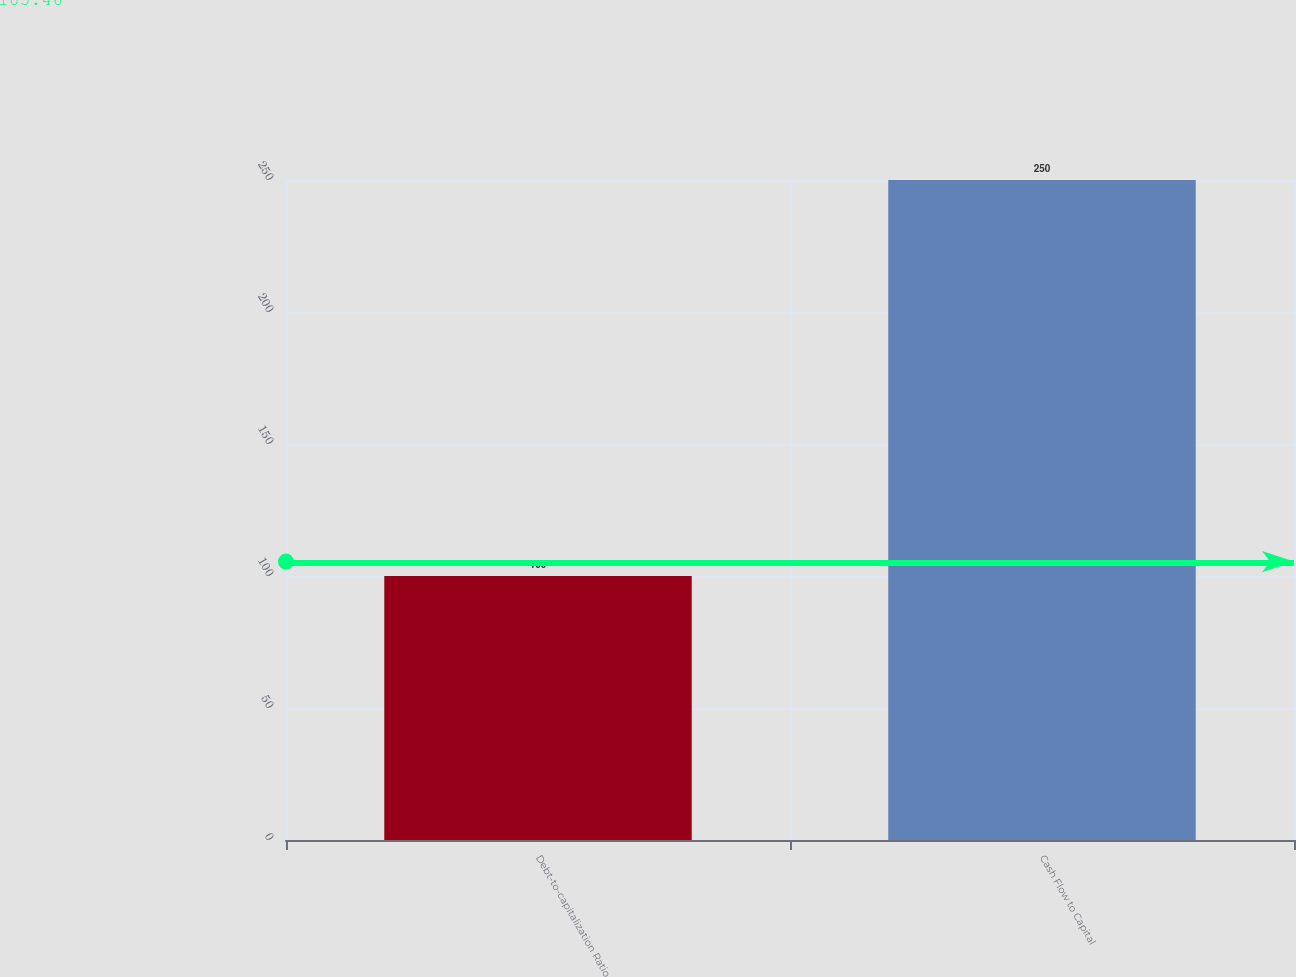Convert chart. <chart><loc_0><loc_0><loc_500><loc_500><bar_chart><fcel>Debt-to-capitalization Ratio<fcel>Cash Flow to Capital<nl><fcel>100<fcel>250<nl></chart> 